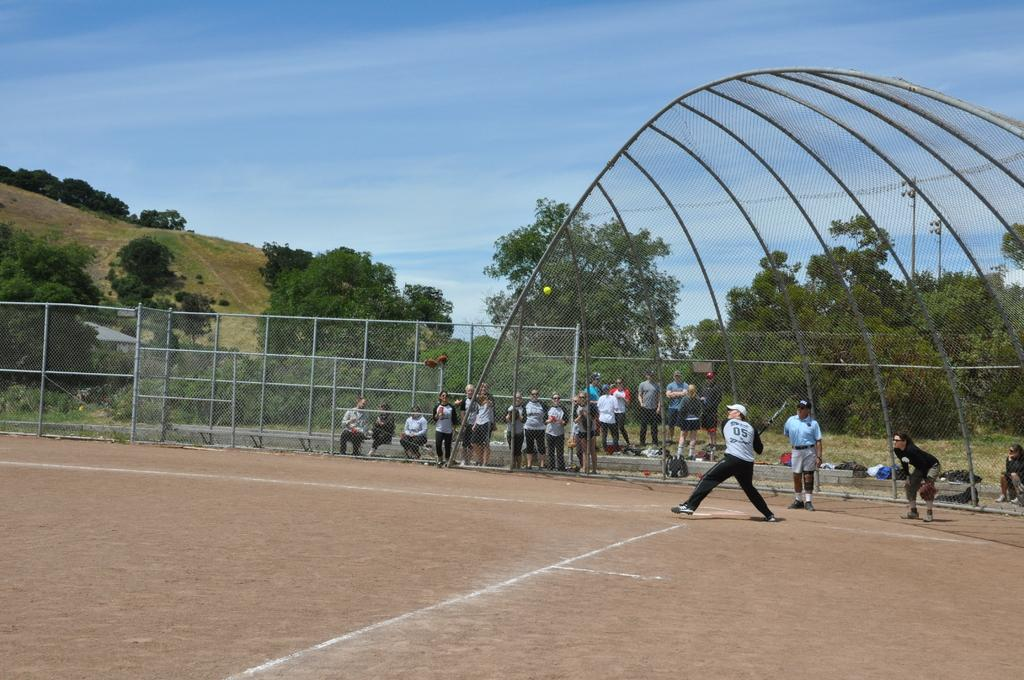<image>
Create a compact narrative representing the image presented. Baseball player wearing jersey number 05 is getting ready to pitch the ball. 